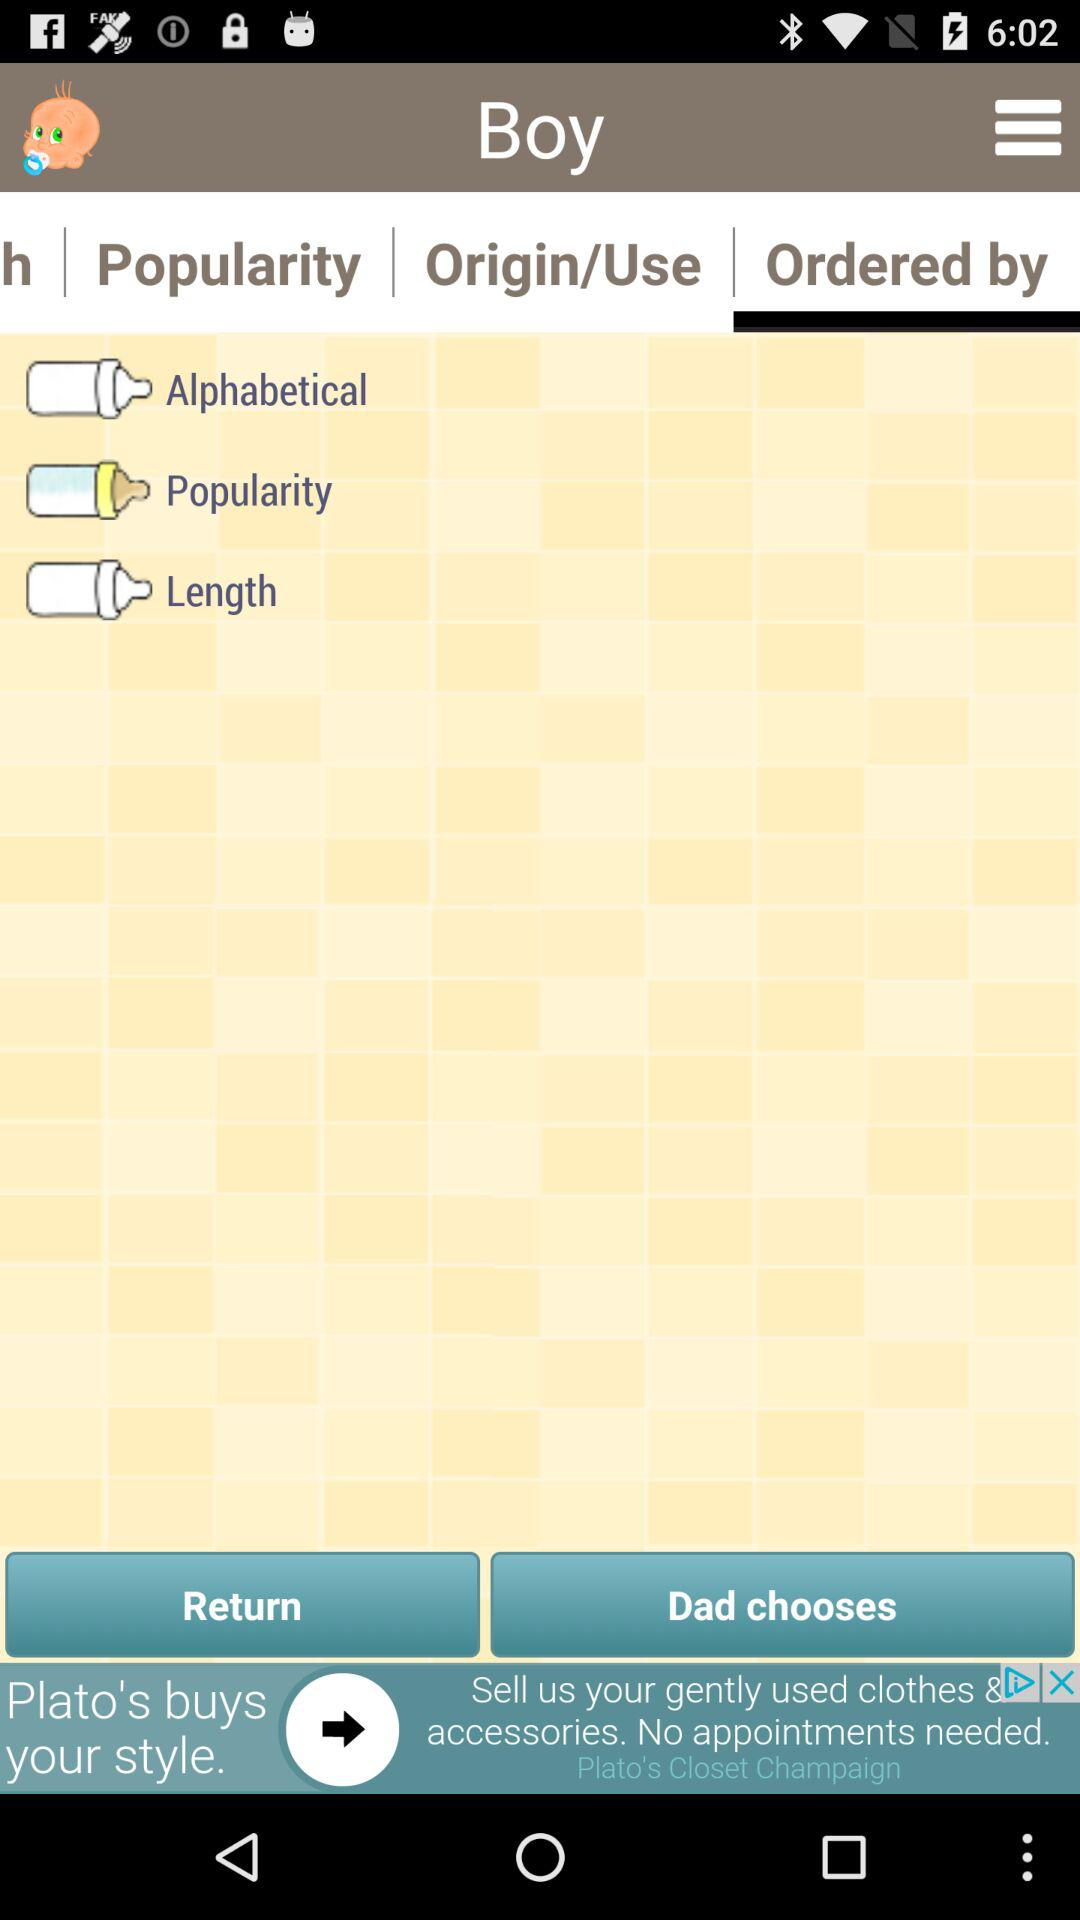What is the mentioned gender? The mentioned gender is boy. 